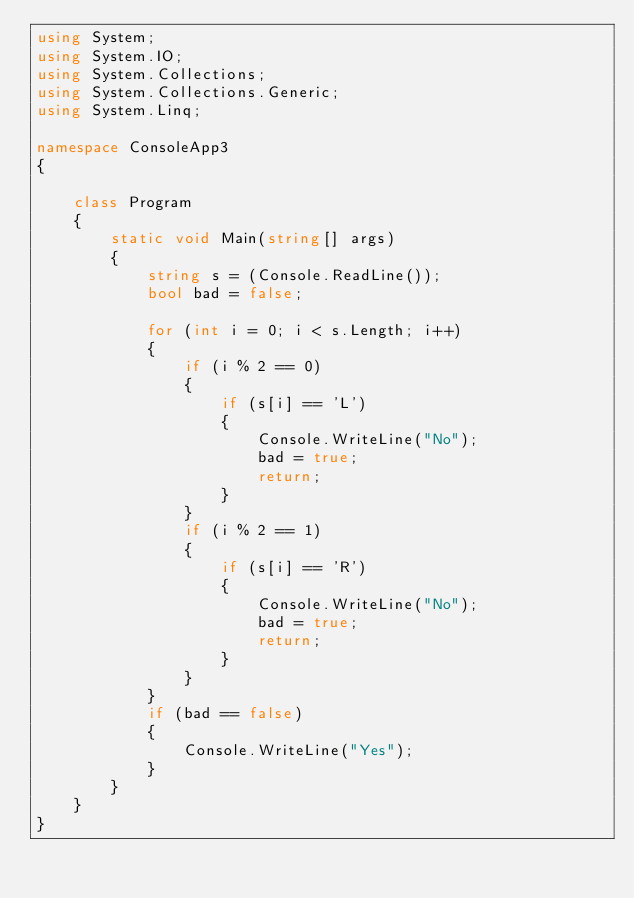Convert code to text. <code><loc_0><loc_0><loc_500><loc_500><_C#_>using System;
using System.IO;
using System.Collections;
using System.Collections.Generic;
using System.Linq;

namespace ConsoleApp3
{

    class Program
    {
        static void Main(string[] args)
        {
            string s = (Console.ReadLine());
            bool bad = false;

            for (int i = 0; i < s.Length; i++)
            {
                if (i % 2 == 0)
                {
                    if (s[i] == 'L')
                    {
                        Console.WriteLine("No");
                        bad = true;
                        return;
                    }
                }
                if (i % 2 == 1)
                {
                    if (s[i] == 'R')
                    {
                        Console.WriteLine("No");
                        bad = true;
                        return;
                    }
                }
            }
            if (bad == false)
            {
                Console.WriteLine("Yes");
            }
        }
    }
}</code> 